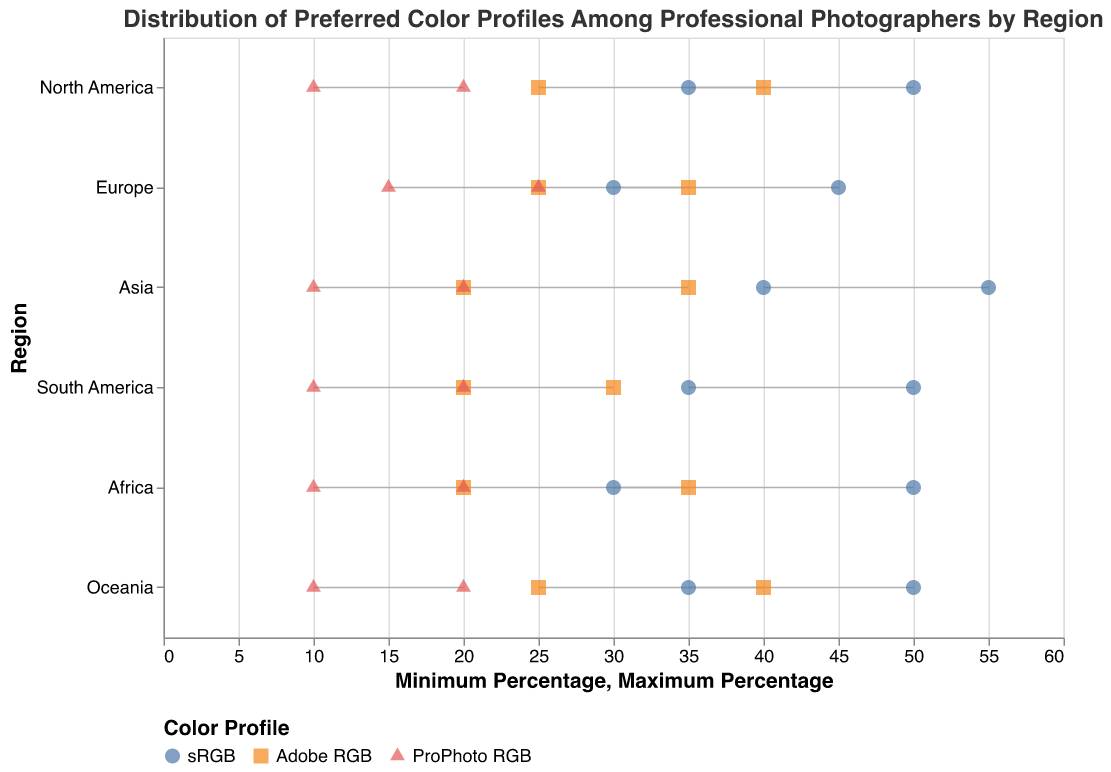What is the title of the plot? The title of the plot is located at the top and reads "Distribution of Preferred Color Profiles Among Professional Photographers by Region."
Answer: Distribution of Preferred Color Profiles Among Professional Photographers by Region Which region has the highest maximum percentage for the sRGB color profile? Looking at the plot, Asia has the highest maximum percentage for the sRGB color profile at 55%.
Answer: Asia In North America, how do the minimum and maximum percentages for Adobe RGB compare to those in Europe? In North America, the Adobe RGB ranges from 25% to 40%, while in Europe it ranges from 25% to 35%. Therefore, North America has a higher maximum percentage.
Answer: North America has a higher maximum percentage What is the range for the ProPhoto RGB profile in Africa? The plot shows the minimum and maximum values for the ProPhoto RGB profile in Africa as 10% and 20%, respectively. The range is the difference between these values.
Answer: 10% Which regions have a minimum percentage of 35 for the sRGB color profile? The regions with a minimum percentage of 35 for the sRGB color profile can be observed from the plot. These regions are North America, South America, and Oceania.
Answer: North America, South America, Oceania Which color profile has the smallest range in Asia? The smallest range in Asia is for ProPhoto RGB, which varies from 10% to 20%, a range of 10%. The other profiles have ranges of 15% (Adobe RGB) and 15% (sRGB).
Answer: ProPhoto RGB Compare the ranges of the Adobe RGB color profile in Europe and Oceania. Which region has the larger range? The Adobe RGB range in Europe is from 25% to 35% (a range of 10%), while in Oceania it is from 25% to 40% (a range of 15%). Hence, Oceania has a larger range.
Answer: Oceania What is the average of the maximum percentages for the sRGB color profile across all regions? To find the average, sum up the maximum percentages for sRGB in all regions and divide by the number of regions: (50 + 45 + 55 + 50 + 50 + 50) / 6 = 300 / 6 = 50.
Answer: 50 Describe the minimum and maximum percentage trend for the sRGB profile across regions. The minimum and maximum percentages for sRGB across regions are relatively consistent, typically ranging between 30%-55%, with Asia having the highest and Europe the lowest minimum percentage.
Answer: Relatively consistent Which color profile is consistently preferred by at least 25% of professionals in all regions? By observing the minimum percentages for each color profile in all regions, sRGB and Adobe RGB both have minimum percentages of 25% or higher across all regions.
Answer: sRGB, Adobe RGB 